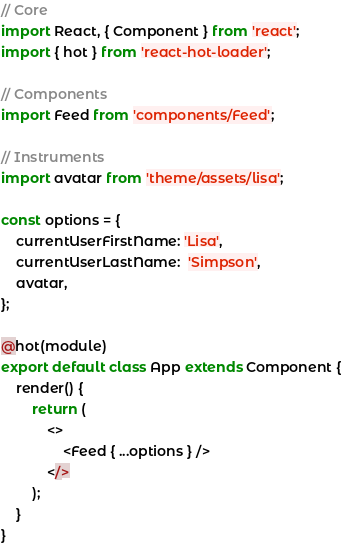Convert code to text. <code><loc_0><loc_0><loc_500><loc_500><_JavaScript_>// Core
import React, { Component } from 'react';
import { hot } from 'react-hot-loader';

// Components
import Feed from 'components/Feed';

// Instruments
import avatar from 'theme/assets/lisa';

const options = {
    currentUserFirstName: 'Lisa',
    currentUserLastName:  'Simpson',
    avatar,
};

@hot(module)
export default class App extends Component {
    render() {
        return (
            <>
                <Feed { ...options } />
            </>
        );
    }
}
</code> 